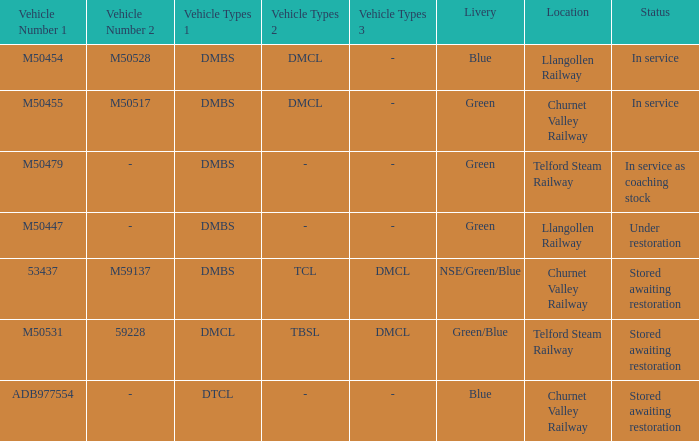What status is the vehicle types of dmbs+tcl+dmcl? Stored awaiting restoration. 